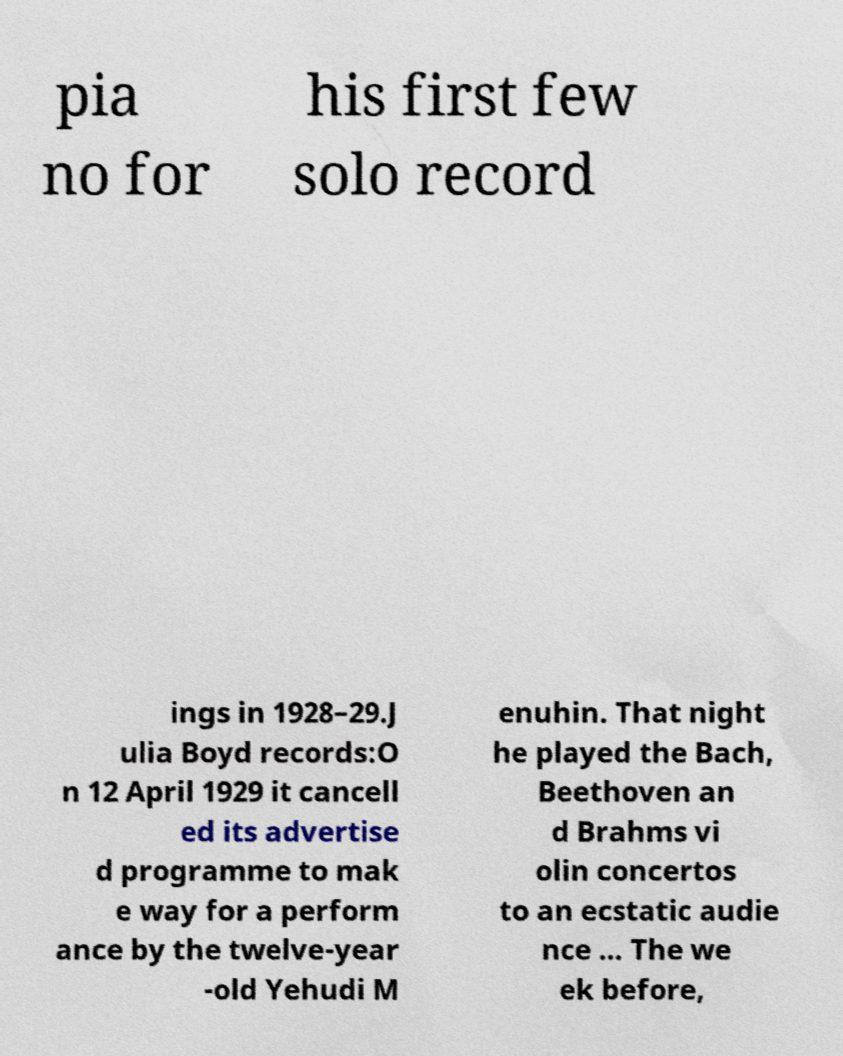What messages or text are displayed in this image? I need them in a readable, typed format. pia no for his first few solo record ings in 1928–29.J ulia Boyd records:O n 12 April 1929 it cancell ed its advertise d programme to mak e way for a perform ance by the twelve-year -old Yehudi M enuhin. That night he played the Bach, Beethoven an d Brahms vi olin concertos to an ecstatic audie nce ... The we ek before, 